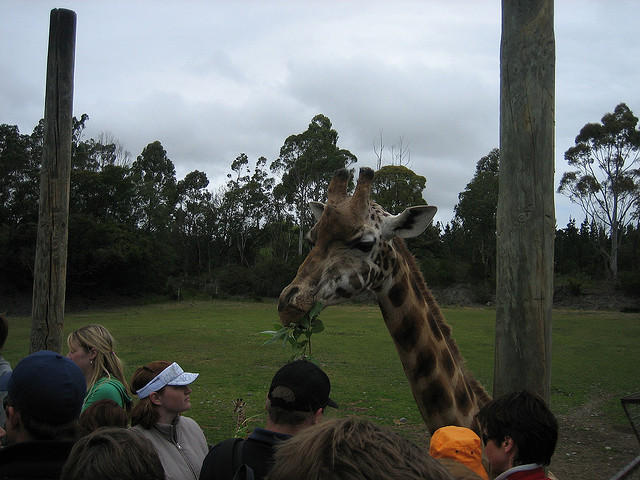<image>What do you think that giraffe is thinking? It is unknown what the giraffe is thinking. What do you think that giraffe is thinking? I don't know what the giraffe is thinking. It can be thinking about its food or feeling hungry. 